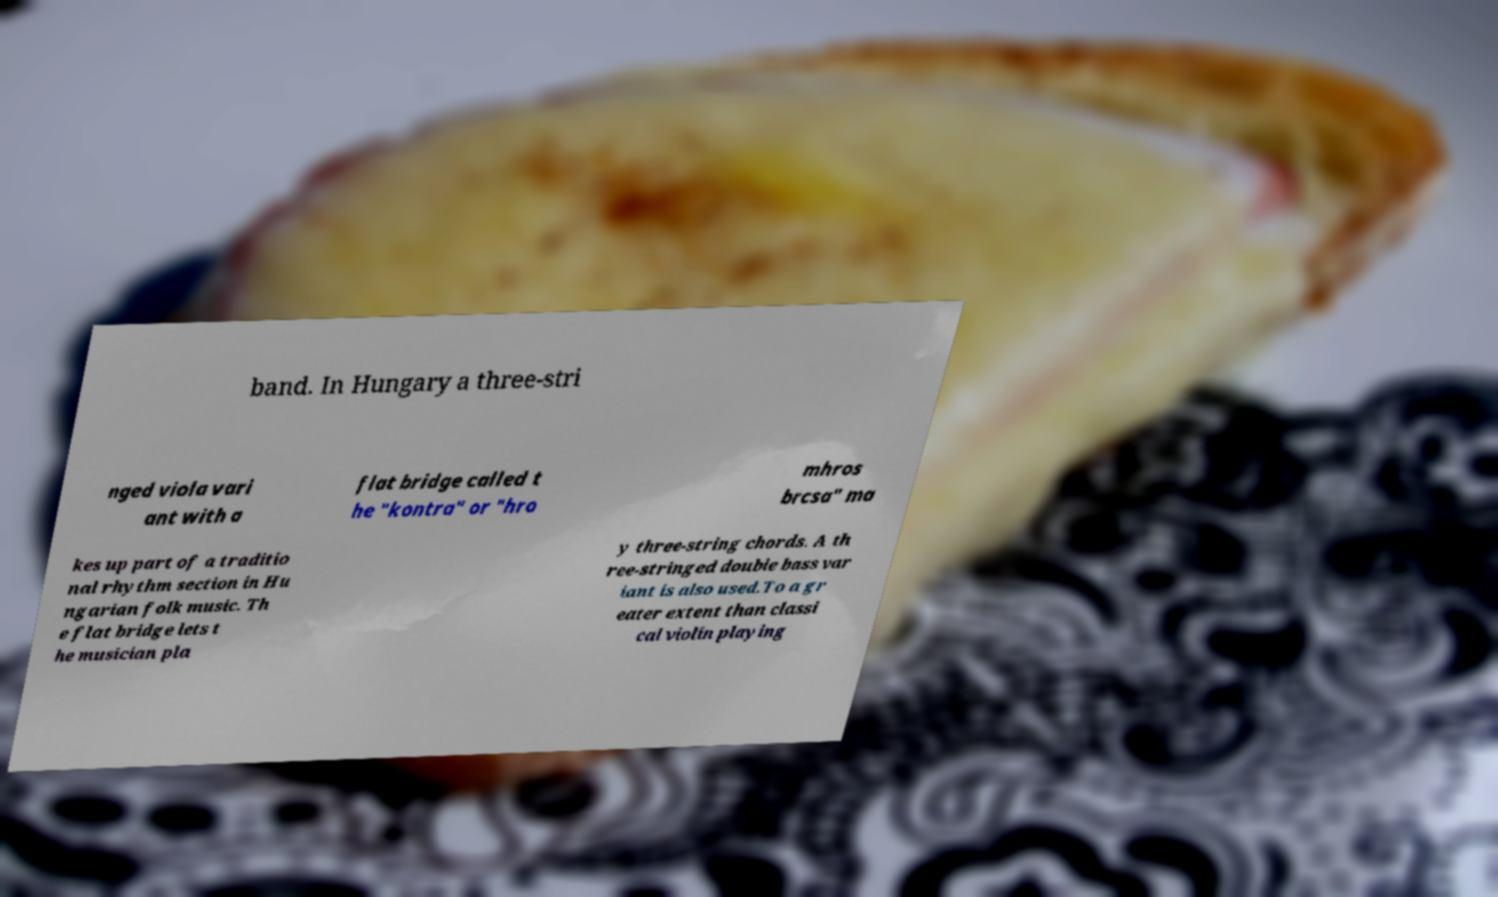Could you assist in decoding the text presented in this image and type it out clearly? band. In Hungary a three-stri nged viola vari ant with a flat bridge called t he "kontra" or "hro mhros brcsa" ma kes up part of a traditio nal rhythm section in Hu ngarian folk music. Th e flat bridge lets t he musician pla y three-string chords. A th ree-stringed double bass var iant is also used.To a gr eater extent than classi cal violin playing 